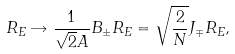Convert formula to latex. <formula><loc_0><loc_0><loc_500><loc_500>R _ { E } \rightarrow \frac { 1 } { \sqrt { 2 } A } B _ { \pm } R _ { E } = \sqrt { \frac { 2 } { N } } J _ { \mp } R _ { E } ,</formula> 